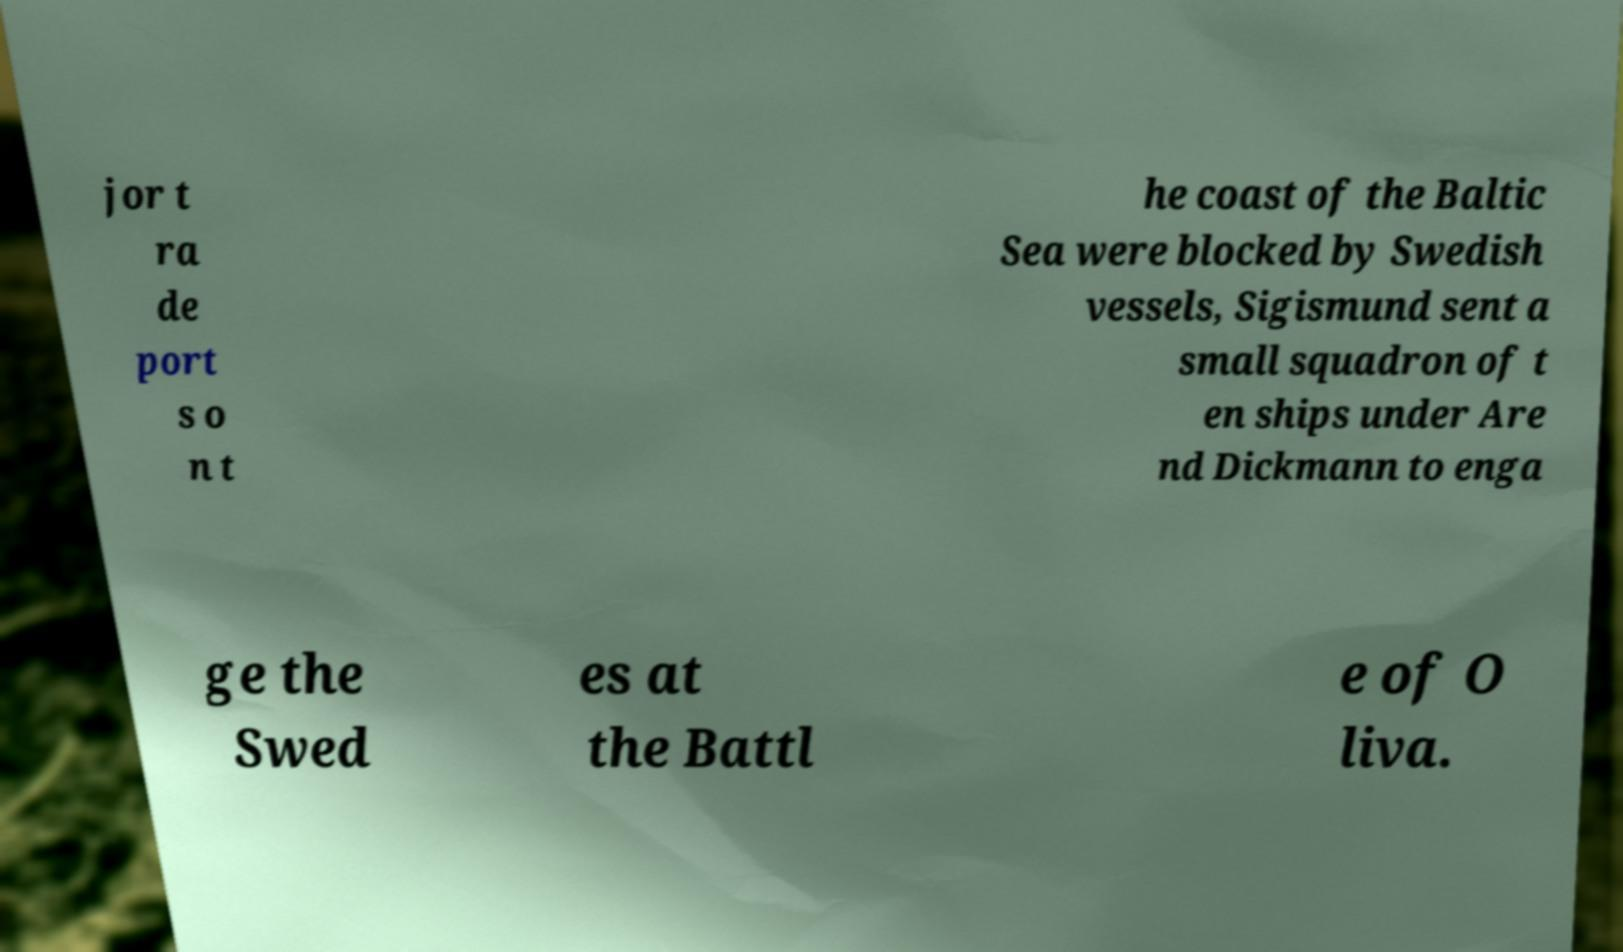I need the written content from this picture converted into text. Can you do that? jor t ra de port s o n t he coast of the Baltic Sea were blocked by Swedish vessels, Sigismund sent a small squadron of t en ships under Are nd Dickmann to enga ge the Swed es at the Battl e of O liva. 